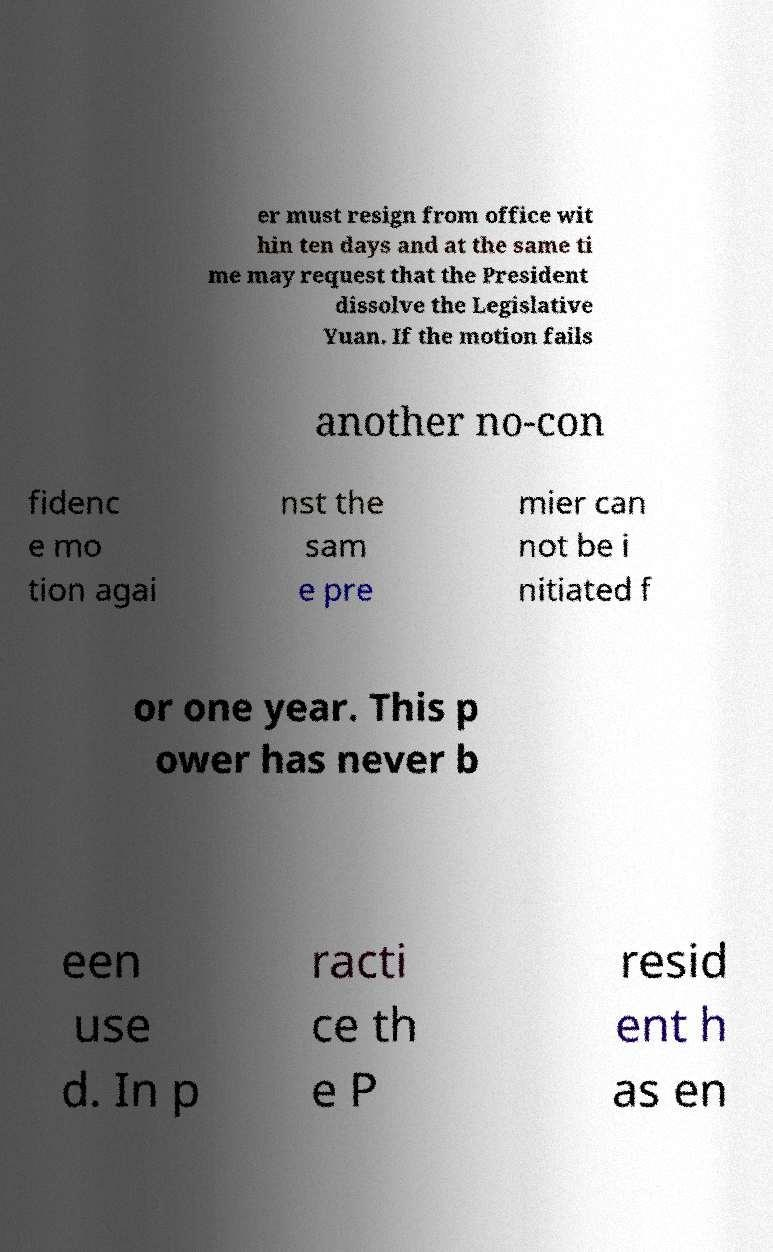Please identify and transcribe the text found in this image. er must resign from office wit hin ten days and at the same ti me may request that the President dissolve the Legislative Yuan. If the motion fails another no-con fidenc e mo tion agai nst the sam e pre mier can not be i nitiated f or one year. This p ower has never b een use d. In p racti ce th e P resid ent h as en 